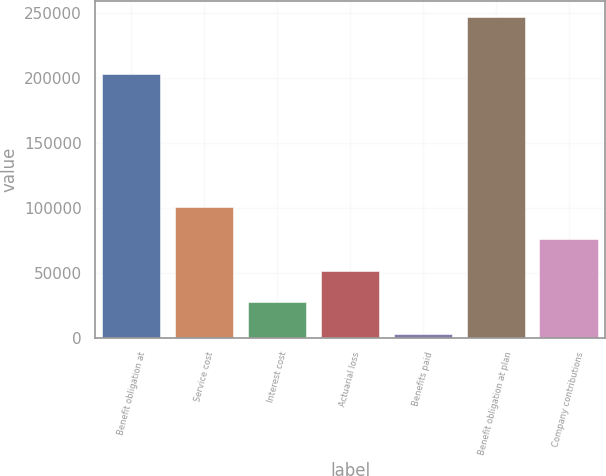Convert chart. <chart><loc_0><loc_0><loc_500><loc_500><bar_chart><fcel>Benefit obligation at<fcel>Service cost<fcel>Interest cost<fcel>Actuarial loss<fcel>Benefits paid<fcel>Benefit obligation at plan<fcel>Company contributions<nl><fcel>203292<fcel>100416<fcel>27131.2<fcel>51559.4<fcel>2703<fcel>246985<fcel>75987.6<nl></chart> 